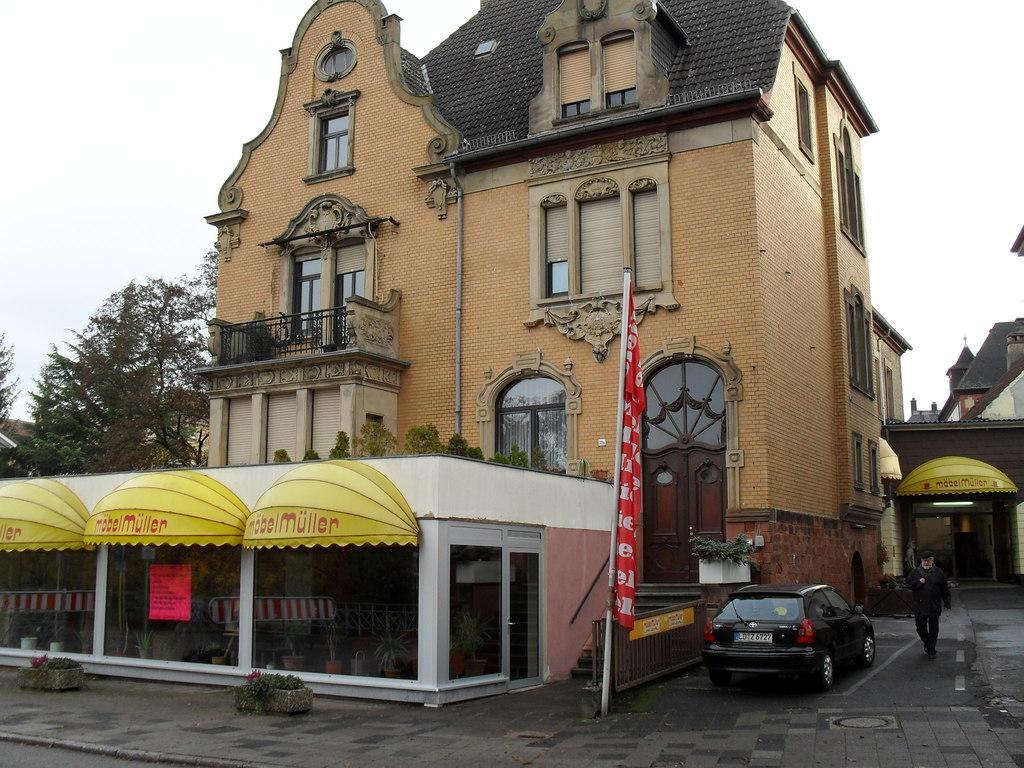Could you give a brief overview of what you see in this image? In this picture we can see a few buildings, there are windows, grills, trees, flower pots and doors. We can also see there is a vehicle and a person, in the background we can see the sky. 